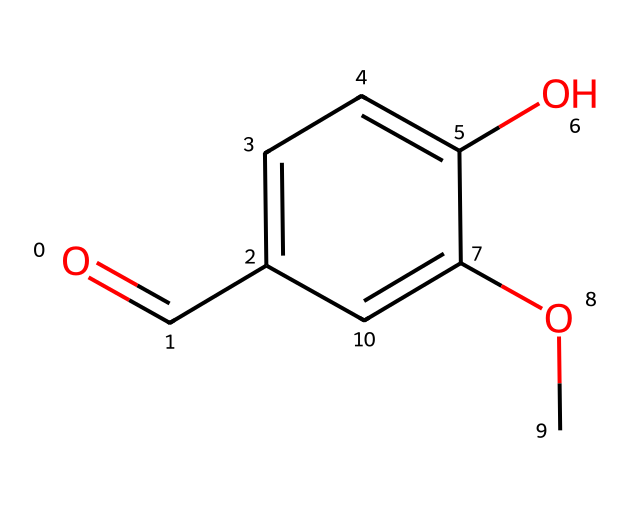What is the name of this compound? The chemical structure corresponds to vanillin, a well-known flavor compound commonly used in food and fragrances.
Answer: vanillin How many carbon atoms are in the structure? By examining the structure, we can identify the carbon atoms in the structure, which total to eight.
Answer: 8 What functional groups are present in this compound? The structure of vanillin contains a carbonyl group (C=O) and a methoxy group (–OCH3), which are characteristic functional groups contributing to its properties.
Answer: carbonyl and methoxy How many hydrogen atoms are associated with the carbon atoms in the structure? The total hydrogen atoms can be calculated based on the carbon count and their bonding, yielding eight hydrogen atoms in this molecule.
Answer: 8 What type of intermolecular interactions can vanillin partake in due to its functional groups? The carbonyl and hydroxyl groups in vanillin facilitate hydrogen bonding, a crucial type of intermolecular interaction for solubility and fragrance properties.
Answer: hydrogen bonding What property makes vanillin suitable for flavoring? Vanillin's pleasant aromatic structure, attributed to its specific arrangement of carbon and functional groups, makes it a favored choice for flavoring.
Answer: aromaticity 